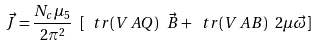Convert formula to latex. <formula><loc_0><loc_0><loc_500><loc_500>\vec { J } = \frac { N _ { c } \mu _ { 5 } } { 2 \pi ^ { 2 } } \ [ \ t r ( V \, A Q ) \ \vec { B } + \ t r ( V \, A B ) \ 2 \mu \vec { \omega } ]</formula> 